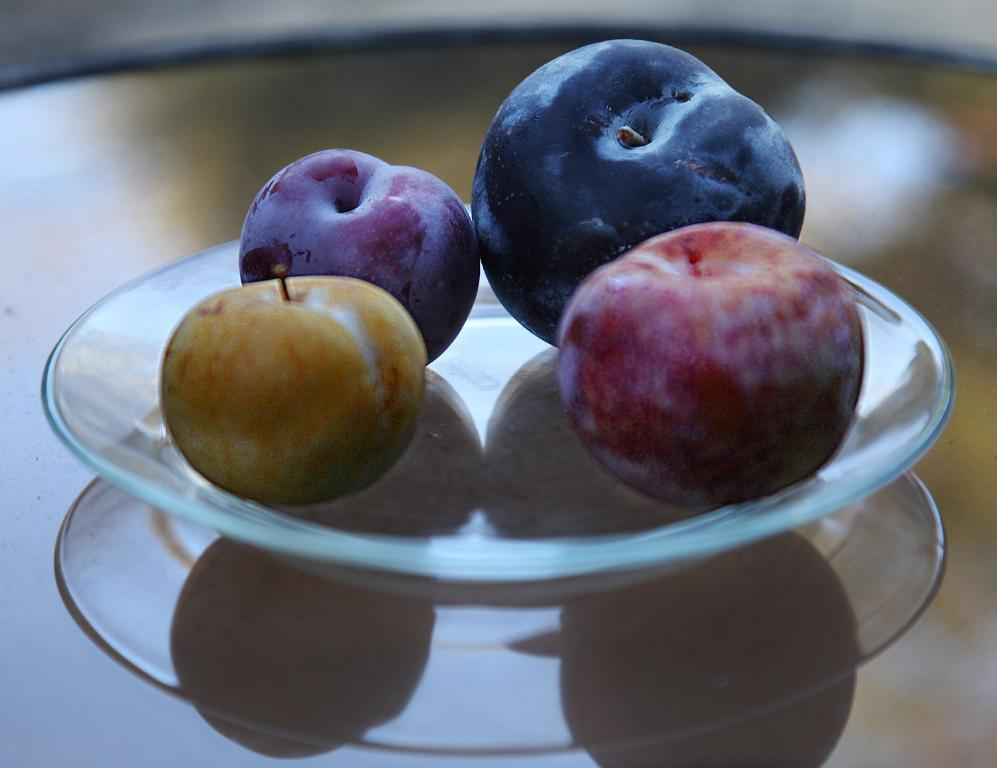What is on the serving plate in the image? The serving plate contains fruits. Where is the serving plate located? The serving plate is placed on a table. How many cats are sitting on the serving plate in the image? There are no cats present on the serving plate or in the image. 